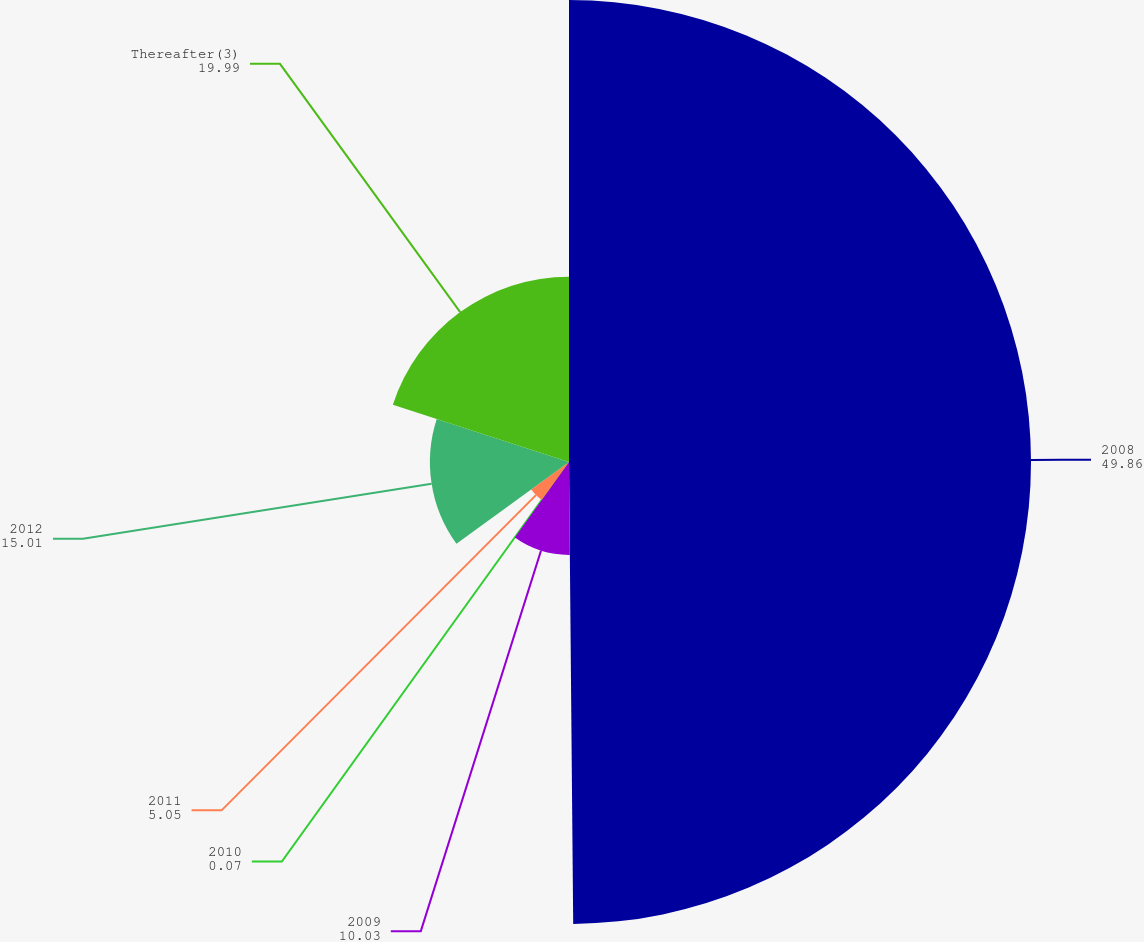Convert chart. <chart><loc_0><loc_0><loc_500><loc_500><pie_chart><fcel>2008<fcel>2009<fcel>2010<fcel>2011<fcel>2012<fcel>Thereafter(3)<nl><fcel>49.86%<fcel>10.03%<fcel>0.07%<fcel>5.05%<fcel>15.01%<fcel>19.99%<nl></chart> 